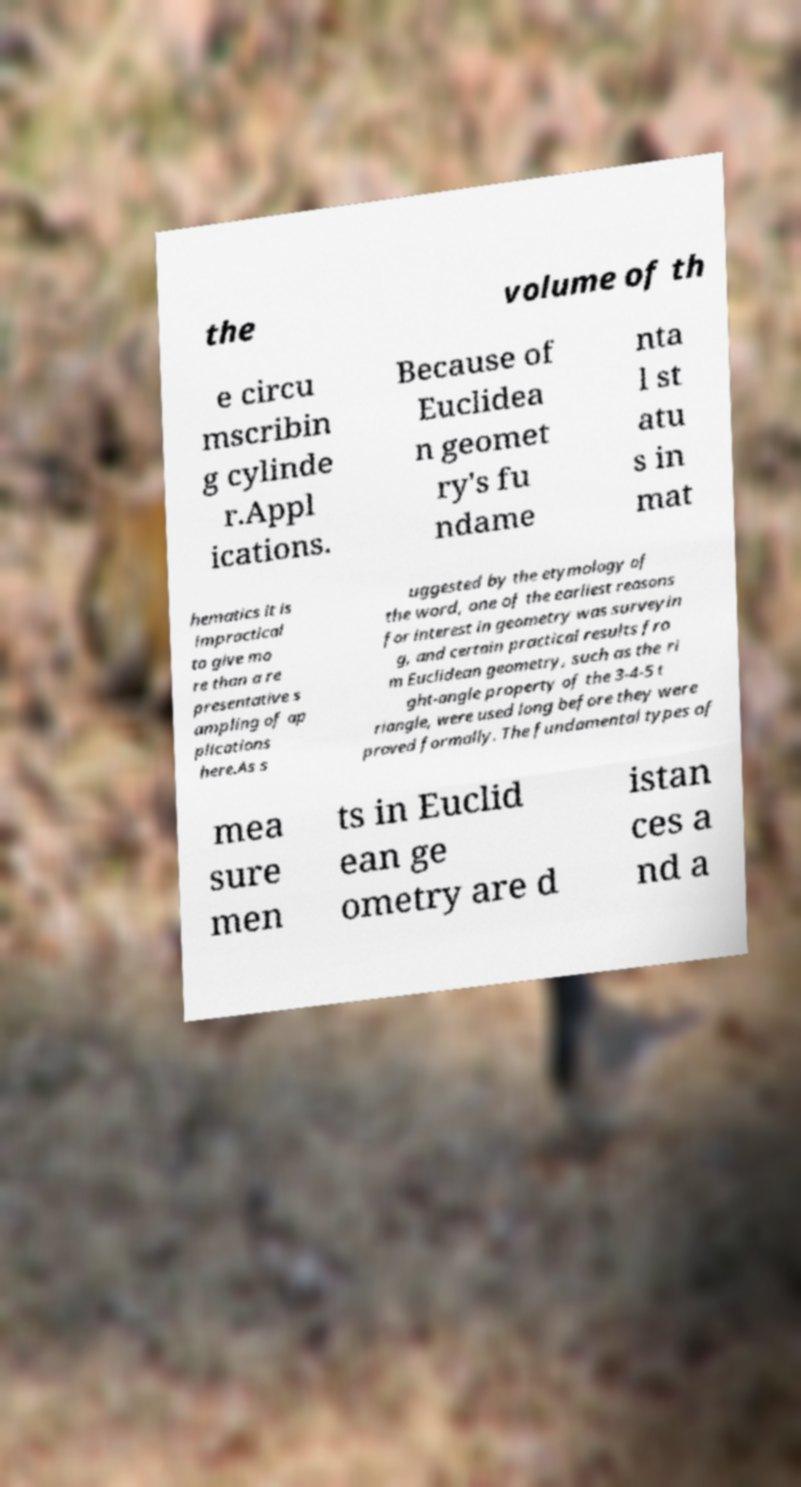Please identify and transcribe the text found in this image. the volume of th e circu mscribin g cylinde r.Appl ications. Because of Euclidea n geomet ry's fu ndame nta l st atu s in mat hematics it is impractical to give mo re than a re presentative s ampling of ap plications here.As s uggested by the etymology of the word, one of the earliest reasons for interest in geometry was surveyin g, and certain practical results fro m Euclidean geometry, such as the ri ght-angle property of the 3-4-5 t riangle, were used long before they were proved formally. The fundamental types of mea sure men ts in Euclid ean ge ometry are d istan ces a nd a 